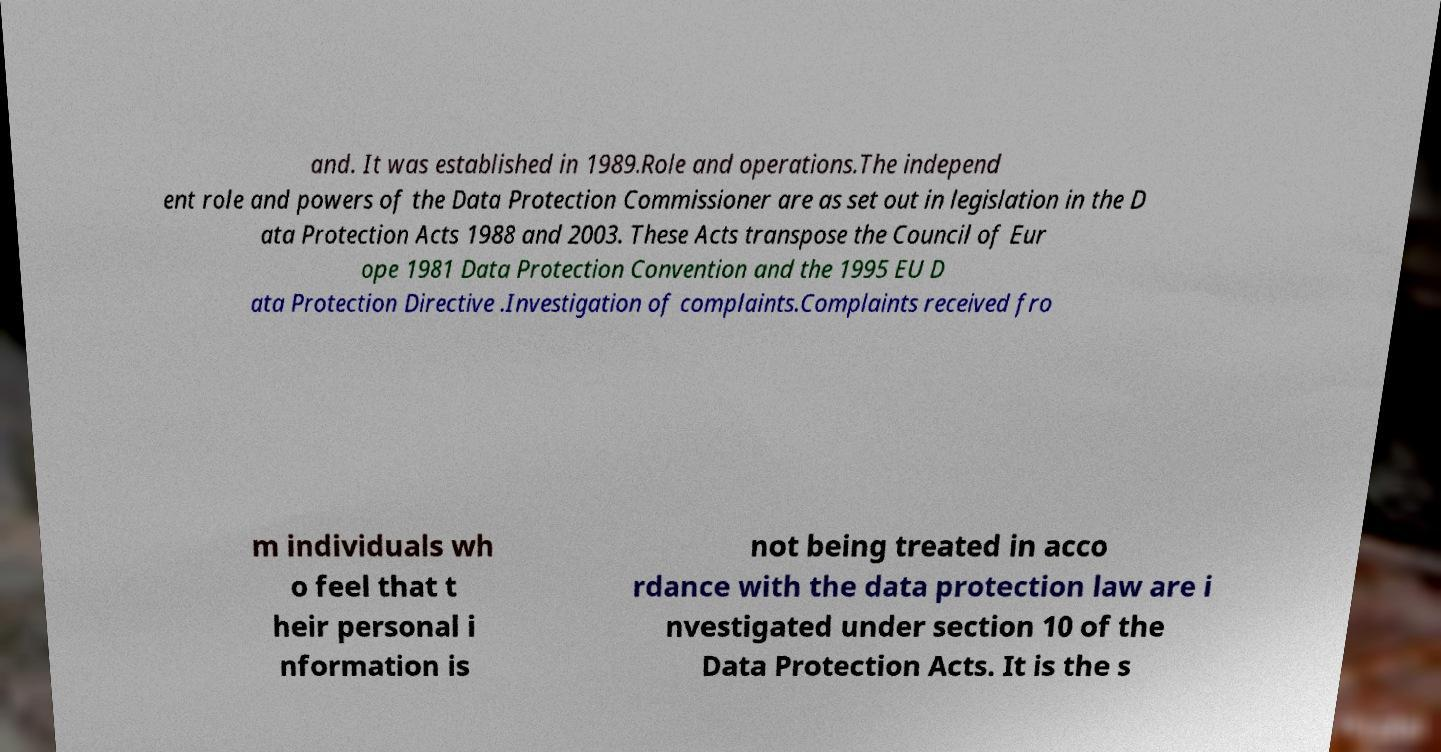Could you extract and type out the text from this image? and. It was established in 1989.Role and operations.The independ ent role and powers of the Data Protection Commissioner are as set out in legislation in the D ata Protection Acts 1988 and 2003. These Acts transpose the Council of Eur ope 1981 Data Protection Convention and the 1995 EU D ata Protection Directive .Investigation of complaints.Complaints received fro m individuals wh o feel that t heir personal i nformation is not being treated in acco rdance with the data protection law are i nvestigated under section 10 of the Data Protection Acts. It is the s 